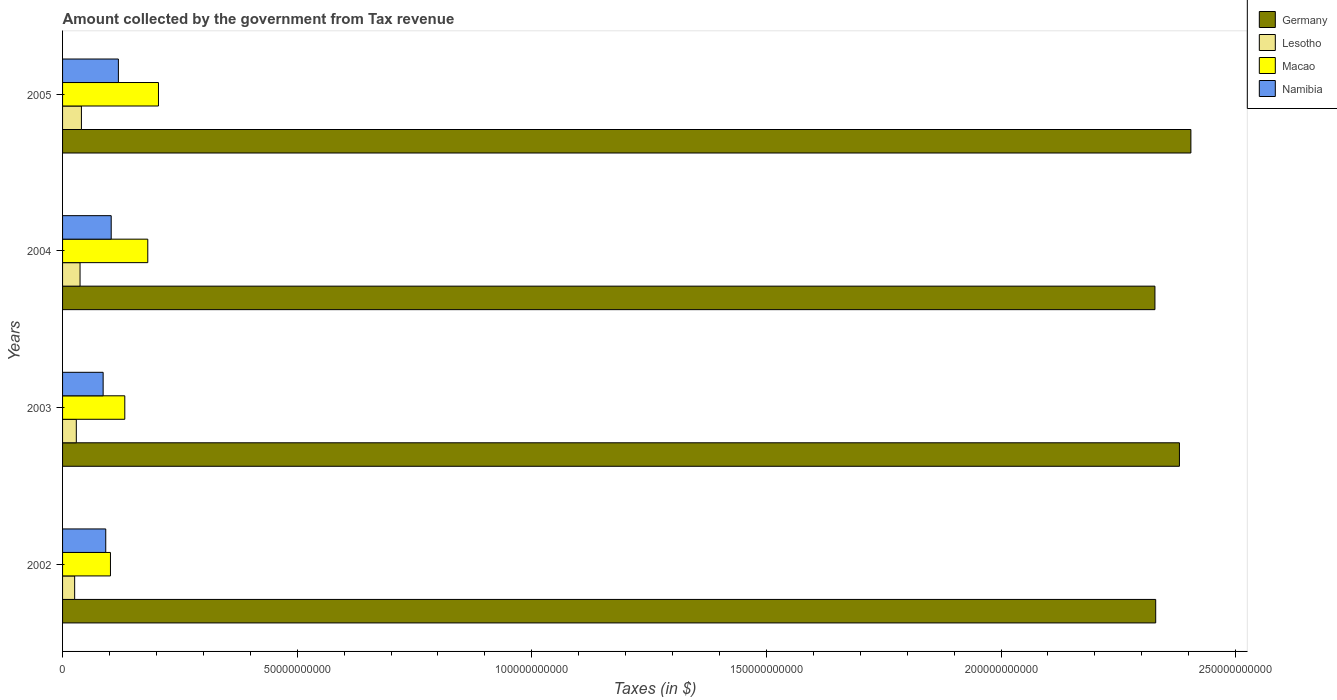How many different coloured bars are there?
Provide a succinct answer. 4. How many groups of bars are there?
Your response must be concise. 4. Are the number of bars per tick equal to the number of legend labels?
Make the answer very short. Yes. Are the number of bars on each tick of the Y-axis equal?
Provide a succinct answer. Yes. How many bars are there on the 1st tick from the bottom?
Give a very brief answer. 4. What is the label of the 4th group of bars from the top?
Offer a terse response. 2002. In how many cases, is the number of bars for a given year not equal to the number of legend labels?
Give a very brief answer. 0. What is the amount collected by the government from tax revenue in Germany in 2002?
Make the answer very short. 2.33e+11. Across all years, what is the maximum amount collected by the government from tax revenue in Germany?
Keep it short and to the point. 2.40e+11. Across all years, what is the minimum amount collected by the government from tax revenue in Lesotho?
Keep it short and to the point. 2.58e+09. In which year was the amount collected by the government from tax revenue in Lesotho minimum?
Your answer should be compact. 2002. What is the total amount collected by the government from tax revenue in Germany in the graph?
Make the answer very short. 9.44e+11. What is the difference between the amount collected by the government from tax revenue in Lesotho in 2002 and that in 2003?
Give a very brief answer. -3.54e+08. What is the difference between the amount collected by the government from tax revenue in Namibia in 2003 and the amount collected by the government from tax revenue in Lesotho in 2002?
Ensure brevity in your answer.  6.07e+09. What is the average amount collected by the government from tax revenue in Germany per year?
Your answer should be very brief. 2.36e+11. In the year 2002, what is the difference between the amount collected by the government from tax revenue in Macao and amount collected by the government from tax revenue in Lesotho?
Offer a very short reply. 7.63e+09. What is the ratio of the amount collected by the government from tax revenue in Lesotho in 2003 to that in 2004?
Ensure brevity in your answer.  0.79. Is the amount collected by the government from tax revenue in Germany in 2004 less than that in 2005?
Keep it short and to the point. Yes. Is the difference between the amount collected by the government from tax revenue in Macao in 2004 and 2005 greater than the difference between the amount collected by the government from tax revenue in Lesotho in 2004 and 2005?
Make the answer very short. No. What is the difference between the highest and the second highest amount collected by the government from tax revenue in Namibia?
Make the answer very short. 1.53e+09. What is the difference between the highest and the lowest amount collected by the government from tax revenue in Namibia?
Make the answer very short. 3.25e+09. Is it the case that in every year, the sum of the amount collected by the government from tax revenue in Macao and amount collected by the government from tax revenue in Namibia is greater than the sum of amount collected by the government from tax revenue in Germany and amount collected by the government from tax revenue in Lesotho?
Make the answer very short. Yes. What does the 2nd bar from the top in 2002 represents?
Provide a short and direct response. Macao. What does the 4th bar from the bottom in 2002 represents?
Give a very brief answer. Namibia. Is it the case that in every year, the sum of the amount collected by the government from tax revenue in Macao and amount collected by the government from tax revenue in Namibia is greater than the amount collected by the government from tax revenue in Lesotho?
Provide a short and direct response. Yes. Are all the bars in the graph horizontal?
Keep it short and to the point. Yes. Are the values on the major ticks of X-axis written in scientific E-notation?
Provide a short and direct response. No. Does the graph contain any zero values?
Keep it short and to the point. No. Does the graph contain grids?
Ensure brevity in your answer.  No. Where does the legend appear in the graph?
Your answer should be very brief. Top right. How many legend labels are there?
Offer a terse response. 4. What is the title of the graph?
Offer a terse response. Amount collected by the government from Tax revenue. What is the label or title of the X-axis?
Ensure brevity in your answer.  Taxes (in $). What is the label or title of the Y-axis?
Provide a short and direct response. Years. What is the Taxes (in $) in Germany in 2002?
Offer a terse response. 2.33e+11. What is the Taxes (in $) of Lesotho in 2002?
Your answer should be very brief. 2.58e+09. What is the Taxes (in $) in Macao in 2002?
Offer a terse response. 1.02e+1. What is the Taxes (in $) in Namibia in 2002?
Give a very brief answer. 9.20e+09. What is the Taxes (in $) in Germany in 2003?
Your answer should be very brief. 2.38e+11. What is the Taxes (in $) in Lesotho in 2003?
Offer a very short reply. 2.93e+09. What is the Taxes (in $) in Macao in 2003?
Make the answer very short. 1.33e+1. What is the Taxes (in $) of Namibia in 2003?
Your answer should be very brief. 8.65e+09. What is the Taxes (in $) in Germany in 2004?
Offer a very short reply. 2.33e+11. What is the Taxes (in $) in Lesotho in 2004?
Your response must be concise. 3.72e+09. What is the Taxes (in $) in Macao in 2004?
Your response must be concise. 1.82e+1. What is the Taxes (in $) in Namibia in 2004?
Provide a short and direct response. 1.04e+1. What is the Taxes (in $) in Germany in 2005?
Give a very brief answer. 2.40e+11. What is the Taxes (in $) in Lesotho in 2005?
Provide a succinct answer. 4.02e+09. What is the Taxes (in $) of Macao in 2005?
Keep it short and to the point. 2.04e+1. What is the Taxes (in $) of Namibia in 2005?
Offer a very short reply. 1.19e+1. Across all years, what is the maximum Taxes (in $) in Germany?
Make the answer very short. 2.40e+11. Across all years, what is the maximum Taxes (in $) of Lesotho?
Your response must be concise. 4.02e+09. Across all years, what is the maximum Taxes (in $) in Macao?
Give a very brief answer. 2.04e+1. Across all years, what is the maximum Taxes (in $) of Namibia?
Give a very brief answer. 1.19e+1. Across all years, what is the minimum Taxes (in $) in Germany?
Provide a succinct answer. 2.33e+11. Across all years, what is the minimum Taxes (in $) of Lesotho?
Provide a succinct answer. 2.58e+09. Across all years, what is the minimum Taxes (in $) in Macao?
Make the answer very short. 1.02e+1. Across all years, what is the minimum Taxes (in $) in Namibia?
Provide a short and direct response. 8.65e+09. What is the total Taxes (in $) of Germany in the graph?
Your response must be concise. 9.44e+11. What is the total Taxes (in $) in Lesotho in the graph?
Ensure brevity in your answer.  1.32e+1. What is the total Taxes (in $) of Macao in the graph?
Give a very brief answer. 6.21e+1. What is the total Taxes (in $) in Namibia in the graph?
Give a very brief answer. 4.01e+1. What is the difference between the Taxes (in $) of Germany in 2002 and that in 2003?
Offer a terse response. -5.06e+09. What is the difference between the Taxes (in $) of Lesotho in 2002 and that in 2003?
Your response must be concise. -3.54e+08. What is the difference between the Taxes (in $) of Macao in 2002 and that in 2003?
Your answer should be compact. -3.05e+09. What is the difference between the Taxes (in $) in Namibia in 2002 and that in 2003?
Keep it short and to the point. 5.58e+08. What is the difference between the Taxes (in $) in Germany in 2002 and that in 2004?
Ensure brevity in your answer.  1.60e+08. What is the difference between the Taxes (in $) of Lesotho in 2002 and that in 2004?
Your answer should be compact. -1.15e+09. What is the difference between the Taxes (in $) of Macao in 2002 and that in 2004?
Offer a terse response. -7.95e+09. What is the difference between the Taxes (in $) in Namibia in 2002 and that in 2004?
Provide a succinct answer. -1.16e+09. What is the difference between the Taxes (in $) of Germany in 2002 and that in 2005?
Offer a very short reply. -7.50e+09. What is the difference between the Taxes (in $) in Lesotho in 2002 and that in 2005?
Keep it short and to the point. -1.44e+09. What is the difference between the Taxes (in $) of Macao in 2002 and that in 2005?
Provide a succinct answer. -1.02e+1. What is the difference between the Taxes (in $) of Namibia in 2002 and that in 2005?
Your answer should be very brief. -2.69e+09. What is the difference between the Taxes (in $) of Germany in 2003 and that in 2004?
Give a very brief answer. 5.22e+09. What is the difference between the Taxes (in $) in Lesotho in 2003 and that in 2004?
Provide a short and direct response. -7.94e+08. What is the difference between the Taxes (in $) of Macao in 2003 and that in 2004?
Your response must be concise. -4.90e+09. What is the difference between the Taxes (in $) of Namibia in 2003 and that in 2004?
Keep it short and to the point. -1.72e+09. What is the difference between the Taxes (in $) in Germany in 2003 and that in 2005?
Give a very brief answer. -2.44e+09. What is the difference between the Taxes (in $) in Lesotho in 2003 and that in 2005?
Provide a short and direct response. -1.09e+09. What is the difference between the Taxes (in $) in Macao in 2003 and that in 2005?
Ensure brevity in your answer.  -7.18e+09. What is the difference between the Taxes (in $) of Namibia in 2003 and that in 2005?
Give a very brief answer. -3.25e+09. What is the difference between the Taxes (in $) of Germany in 2004 and that in 2005?
Give a very brief answer. -7.66e+09. What is the difference between the Taxes (in $) in Lesotho in 2004 and that in 2005?
Provide a succinct answer. -2.95e+08. What is the difference between the Taxes (in $) of Macao in 2004 and that in 2005?
Ensure brevity in your answer.  -2.28e+09. What is the difference between the Taxes (in $) in Namibia in 2004 and that in 2005?
Offer a very short reply. -1.53e+09. What is the difference between the Taxes (in $) of Germany in 2002 and the Taxes (in $) of Lesotho in 2003?
Your answer should be very brief. 2.30e+11. What is the difference between the Taxes (in $) in Germany in 2002 and the Taxes (in $) in Macao in 2003?
Keep it short and to the point. 2.20e+11. What is the difference between the Taxes (in $) in Germany in 2002 and the Taxes (in $) in Namibia in 2003?
Your response must be concise. 2.24e+11. What is the difference between the Taxes (in $) of Lesotho in 2002 and the Taxes (in $) of Macao in 2003?
Your answer should be compact. -1.07e+1. What is the difference between the Taxes (in $) in Lesotho in 2002 and the Taxes (in $) in Namibia in 2003?
Offer a very short reply. -6.07e+09. What is the difference between the Taxes (in $) of Macao in 2002 and the Taxes (in $) of Namibia in 2003?
Keep it short and to the point. 1.56e+09. What is the difference between the Taxes (in $) of Germany in 2002 and the Taxes (in $) of Lesotho in 2004?
Offer a terse response. 2.29e+11. What is the difference between the Taxes (in $) in Germany in 2002 and the Taxes (in $) in Macao in 2004?
Make the answer very short. 2.15e+11. What is the difference between the Taxes (in $) of Germany in 2002 and the Taxes (in $) of Namibia in 2004?
Your answer should be very brief. 2.23e+11. What is the difference between the Taxes (in $) in Lesotho in 2002 and the Taxes (in $) in Macao in 2004?
Keep it short and to the point. -1.56e+1. What is the difference between the Taxes (in $) in Lesotho in 2002 and the Taxes (in $) in Namibia in 2004?
Provide a succinct answer. -7.79e+09. What is the difference between the Taxes (in $) in Macao in 2002 and the Taxes (in $) in Namibia in 2004?
Offer a very short reply. -1.59e+08. What is the difference between the Taxes (in $) of Germany in 2002 and the Taxes (in $) of Lesotho in 2005?
Your response must be concise. 2.29e+11. What is the difference between the Taxes (in $) in Germany in 2002 and the Taxes (in $) in Macao in 2005?
Offer a very short reply. 2.13e+11. What is the difference between the Taxes (in $) of Germany in 2002 and the Taxes (in $) of Namibia in 2005?
Ensure brevity in your answer.  2.21e+11. What is the difference between the Taxes (in $) of Lesotho in 2002 and the Taxes (in $) of Macao in 2005?
Your answer should be very brief. -1.79e+1. What is the difference between the Taxes (in $) in Lesotho in 2002 and the Taxes (in $) in Namibia in 2005?
Your response must be concise. -9.32e+09. What is the difference between the Taxes (in $) of Macao in 2002 and the Taxes (in $) of Namibia in 2005?
Provide a short and direct response. -1.69e+09. What is the difference between the Taxes (in $) in Germany in 2003 and the Taxes (in $) in Lesotho in 2004?
Offer a terse response. 2.34e+11. What is the difference between the Taxes (in $) in Germany in 2003 and the Taxes (in $) in Macao in 2004?
Offer a very short reply. 2.20e+11. What is the difference between the Taxes (in $) of Germany in 2003 and the Taxes (in $) of Namibia in 2004?
Your answer should be very brief. 2.28e+11. What is the difference between the Taxes (in $) in Lesotho in 2003 and the Taxes (in $) in Macao in 2004?
Give a very brief answer. -1.52e+1. What is the difference between the Taxes (in $) in Lesotho in 2003 and the Taxes (in $) in Namibia in 2004?
Keep it short and to the point. -7.44e+09. What is the difference between the Taxes (in $) of Macao in 2003 and the Taxes (in $) of Namibia in 2004?
Offer a terse response. 2.90e+09. What is the difference between the Taxes (in $) in Germany in 2003 and the Taxes (in $) in Lesotho in 2005?
Provide a succinct answer. 2.34e+11. What is the difference between the Taxes (in $) of Germany in 2003 and the Taxes (in $) of Macao in 2005?
Provide a succinct answer. 2.18e+11. What is the difference between the Taxes (in $) in Germany in 2003 and the Taxes (in $) in Namibia in 2005?
Give a very brief answer. 2.26e+11. What is the difference between the Taxes (in $) in Lesotho in 2003 and the Taxes (in $) in Macao in 2005?
Provide a succinct answer. -1.75e+1. What is the difference between the Taxes (in $) in Lesotho in 2003 and the Taxes (in $) in Namibia in 2005?
Your answer should be compact. -8.97e+09. What is the difference between the Taxes (in $) in Macao in 2003 and the Taxes (in $) in Namibia in 2005?
Your answer should be very brief. 1.37e+09. What is the difference between the Taxes (in $) of Germany in 2004 and the Taxes (in $) of Lesotho in 2005?
Give a very brief answer. 2.29e+11. What is the difference between the Taxes (in $) in Germany in 2004 and the Taxes (in $) in Macao in 2005?
Provide a short and direct response. 2.12e+11. What is the difference between the Taxes (in $) of Germany in 2004 and the Taxes (in $) of Namibia in 2005?
Provide a short and direct response. 2.21e+11. What is the difference between the Taxes (in $) of Lesotho in 2004 and the Taxes (in $) of Macao in 2005?
Make the answer very short. -1.67e+1. What is the difference between the Taxes (in $) of Lesotho in 2004 and the Taxes (in $) of Namibia in 2005?
Offer a terse response. -8.17e+09. What is the difference between the Taxes (in $) of Macao in 2004 and the Taxes (in $) of Namibia in 2005?
Your response must be concise. 6.26e+09. What is the average Taxes (in $) in Germany per year?
Keep it short and to the point. 2.36e+11. What is the average Taxes (in $) in Lesotho per year?
Provide a short and direct response. 3.31e+09. What is the average Taxes (in $) in Macao per year?
Provide a short and direct response. 1.55e+1. What is the average Taxes (in $) in Namibia per year?
Offer a very short reply. 1.00e+1. In the year 2002, what is the difference between the Taxes (in $) in Germany and Taxes (in $) in Lesotho?
Give a very brief answer. 2.30e+11. In the year 2002, what is the difference between the Taxes (in $) of Germany and Taxes (in $) of Macao?
Keep it short and to the point. 2.23e+11. In the year 2002, what is the difference between the Taxes (in $) in Germany and Taxes (in $) in Namibia?
Keep it short and to the point. 2.24e+11. In the year 2002, what is the difference between the Taxes (in $) of Lesotho and Taxes (in $) of Macao?
Provide a succinct answer. -7.63e+09. In the year 2002, what is the difference between the Taxes (in $) in Lesotho and Taxes (in $) in Namibia?
Ensure brevity in your answer.  -6.63e+09. In the year 2002, what is the difference between the Taxes (in $) in Macao and Taxes (in $) in Namibia?
Provide a succinct answer. 1.00e+09. In the year 2003, what is the difference between the Taxes (in $) in Germany and Taxes (in $) in Lesotho?
Give a very brief answer. 2.35e+11. In the year 2003, what is the difference between the Taxes (in $) of Germany and Taxes (in $) of Macao?
Offer a terse response. 2.25e+11. In the year 2003, what is the difference between the Taxes (in $) of Germany and Taxes (in $) of Namibia?
Provide a short and direct response. 2.29e+11. In the year 2003, what is the difference between the Taxes (in $) of Lesotho and Taxes (in $) of Macao?
Provide a succinct answer. -1.03e+1. In the year 2003, what is the difference between the Taxes (in $) in Lesotho and Taxes (in $) in Namibia?
Offer a very short reply. -5.72e+09. In the year 2003, what is the difference between the Taxes (in $) in Macao and Taxes (in $) in Namibia?
Offer a very short reply. 4.62e+09. In the year 2004, what is the difference between the Taxes (in $) of Germany and Taxes (in $) of Lesotho?
Offer a terse response. 2.29e+11. In the year 2004, what is the difference between the Taxes (in $) in Germany and Taxes (in $) in Macao?
Keep it short and to the point. 2.15e+11. In the year 2004, what is the difference between the Taxes (in $) of Germany and Taxes (in $) of Namibia?
Offer a very short reply. 2.22e+11. In the year 2004, what is the difference between the Taxes (in $) of Lesotho and Taxes (in $) of Macao?
Your answer should be compact. -1.44e+1. In the year 2004, what is the difference between the Taxes (in $) of Lesotho and Taxes (in $) of Namibia?
Your answer should be compact. -6.64e+09. In the year 2004, what is the difference between the Taxes (in $) of Macao and Taxes (in $) of Namibia?
Offer a terse response. 7.79e+09. In the year 2005, what is the difference between the Taxes (in $) of Germany and Taxes (in $) of Lesotho?
Keep it short and to the point. 2.36e+11. In the year 2005, what is the difference between the Taxes (in $) in Germany and Taxes (in $) in Macao?
Your answer should be very brief. 2.20e+11. In the year 2005, what is the difference between the Taxes (in $) in Germany and Taxes (in $) in Namibia?
Provide a succinct answer. 2.29e+11. In the year 2005, what is the difference between the Taxes (in $) of Lesotho and Taxes (in $) of Macao?
Offer a very short reply. -1.64e+1. In the year 2005, what is the difference between the Taxes (in $) of Lesotho and Taxes (in $) of Namibia?
Offer a very short reply. -7.88e+09. In the year 2005, what is the difference between the Taxes (in $) of Macao and Taxes (in $) of Namibia?
Offer a very short reply. 8.54e+09. What is the ratio of the Taxes (in $) in Germany in 2002 to that in 2003?
Offer a terse response. 0.98. What is the ratio of the Taxes (in $) of Lesotho in 2002 to that in 2003?
Provide a succinct answer. 0.88. What is the ratio of the Taxes (in $) of Macao in 2002 to that in 2003?
Ensure brevity in your answer.  0.77. What is the ratio of the Taxes (in $) in Namibia in 2002 to that in 2003?
Your answer should be compact. 1.06. What is the ratio of the Taxes (in $) of Lesotho in 2002 to that in 2004?
Your answer should be very brief. 0.69. What is the ratio of the Taxes (in $) of Macao in 2002 to that in 2004?
Make the answer very short. 0.56. What is the ratio of the Taxes (in $) in Namibia in 2002 to that in 2004?
Your response must be concise. 0.89. What is the ratio of the Taxes (in $) of Germany in 2002 to that in 2005?
Provide a succinct answer. 0.97. What is the ratio of the Taxes (in $) of Lesotho in 2002 to that in 2005?
Your answer should be very brief. 0.64. What is the ratio of the Taxes (in $) in Macao in 2002 to that in 2005?
Give a very brief answer. 0.5. What is the ratio of the Taxes (in $) of Namibia in 2002 to that in 2005?
Provide a succinct answer. 0.77. What is the ratio of the Taxes (in $) in Germany in 2003 to that in 2004?
Your answer should be compact. 1.02. What is the ratio of the Taxes (in $) of Lesotho in 2003 to that in 2004?
Offer a terse response. 0.79. What is the ratio of the Taxes (in $) of Macao in 2003 to that in 2004?
Provide a succinct answer. 0.73. What is the ratio of the Taxes (in $) in Namibia in 2003 to that in 2004?
Your answer should be very brief. 0.83. What is the ratio of the Taxes (in $) of Germany in 2003 to that in 2005?
Give a very brief answer. 0.99. What is the ratio of the Taxes (in $) of Lesotho in 2003 to that in 2005?
Keep it short and to the point. 0.73. What is the ratio of the Taxes (in $) of Macao in 2003 to that in 2005?
Your answer should be compact. 0.65. What is the ratio of the Taxes (in $) in Namibia in 2003 to that in 2005?
Provide a succinct answer. 0.73. What is the ratio of the Taxes (in $) in Germany in 2004 to that in 2005?
Your answer should be compact. 0.97. What is the ratio of the Taxes (in $) of Lesotho in 2004 to that in 2005?
Keep it short and to the point. 0.93. What is the ratio of the Taxes (in $) in Macao in 2004 to that in 2005?
Ensure brevity in your answer.  0.89. What is the ratio of the Taxes (in $) in Namibia in 2004 to that in 2005?
Offer a very short reply. 0.87. What is the difference between the highest and the second highest Taxes (in $) in Germany?
Your answer should be compact. 2.44e+09. What is the difference between the highest and the second highest Taxes (in $) of Lesotho?
Your answer should be compact. 2.95e+08. What is the difference between the highest and the second highest Taxes (in $) in Macao?
Offer a terse response. 2.28e+09. What is the difference between the highest and the second highest Taxes (in $) in Namibia?
Provide a short and direct response. 1.53e+09. What is the difference between the highest and the lowest Taxes (in $) of Germany?
Offer a terse response. 7.66e+09. What is the difference between the highest and the lowest Taxes (in $) in Lesotho?
Provide a short and direct response. 1.44e+09. What is the difference between the highest and the lowest Taxes (in $) in Macao?
Your answer should be very brief. 1.02e+1. What is the difference between the highest and the lowest Taxes (in $) in Namibia?
Your response must be concise. 3.25e+09. 